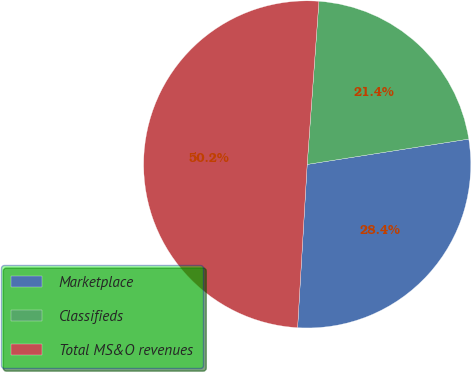Convert chart. <chart><loc_0><loc_0><loc_500><loc_500><pie_chart><fcel>Marketplace<fcel>Classifieds<fcel>Total MS&O revenues<nl><fcel>28.41%<fcel>21.38%<fcel>50.21%<nl></chart> 